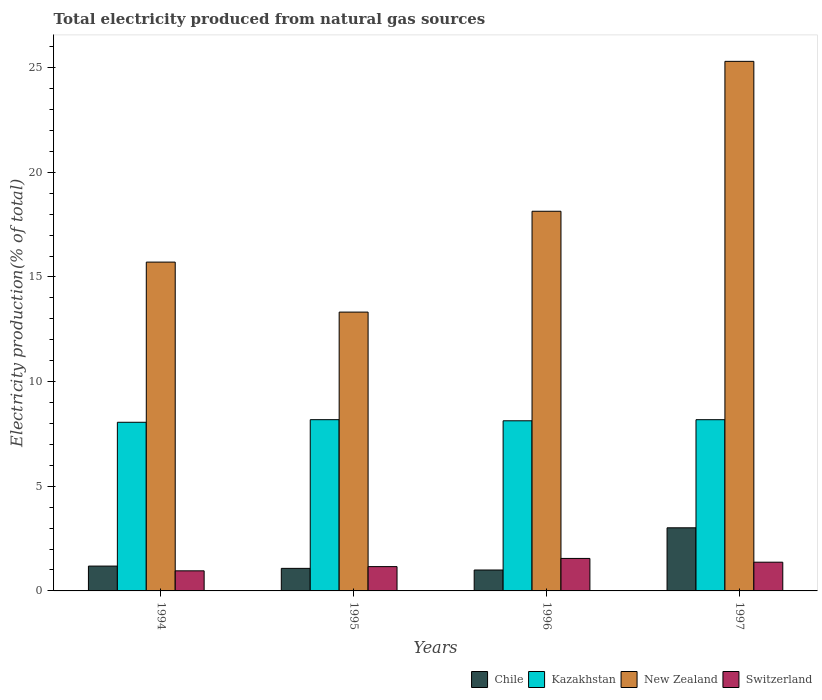Are the number of bars on each tick of the X-axis equal?
Give a very brief answer. Yes. How many bars are there on the 1st tick from the left?
Your response must be concise. 4. What is the label of the 3rd group of bars from the left?
Provide a succinct answer. 1996. In how many cases, is the number of bars for a given year not equal to the number of legend labels?
Provide a short and direct response. 0. What is the total electricity produced in Switzerland in 1994?
Make the answer very short. 0.96. Across all years, what is the maximum total electricity produced in Chile?
Offer a terse response. 3.02. Across all years, what is the minimum total electricity produced in Kazakhstan?
Provide a short and direct response. 8.06. What is the total total electricity produced in New Zealand in the graph?
Give a very brief answer. 72.47. What is the difference between the total electricity produced in Switzerland in 1995 and that in 1997?
Offer a terse response. -0.21. What is the difference between the total electricity produced in Chile in 1997 and the total electricity produced in Switzerland in 1995?
Offer a very short reply. 1.85. What is the average total electricity produced in Switzerland per year?
Your response must be concise. 1.26. In the year 1994, what is the difference between the total electricity produced in Switzerland and total electricity produced in New Zealand?
Your answer should be compact. -14.75. In how many years, is the total electricity produced in Switzerland greater than 9 %?
Provide a succinct answer. 0. What is the ratio of the total electricity produced in Switzerland in 1994 to that in 1995?
Provide a succinct answer. 0.83. Is the difference between the total electricity produced in Switzerland in 1995 and 1996 greater than the difference between the total electricity produced in New Zealand in 1995 and 1996?
Your answer should be compact. Yes. What is the difference between the highest and the second highest total electricity produced in Chile?
Provide a short and direct response. 1.83. What is the difference between the highest and the lowest total electricity produced in New Zealand?
Make the answer very short. 11.98. In how many years, is the total electricity produced in Switzerland greater than the average total electricity produced in Switzerland taken over all years?
Provide a succinct answer. 2. Is the sum of the total electricity produced in Chile in 1994 and 1997 greater than the maximum total electricity produced in Switzerland across all years?
Provide a succinct answer. Yes. What does the 4th bar from the left in 1996 represents?
Provide a short and direct response. Switzerland. What does the 2nd bar from the right in 1997 represents?
Your answer should be very brief. New Zealand. Is it the case that in every year, the sum of the total electricity produced in Chile and total electricity produced in Kazakhstan is greater than the total electricity produced in New Zealand?
Your response must be concise. No. How many bars are there?
Provide a succinct answer. 16. Are all the bars in the graph horizontal?
Offer a very short reply. No. How many years are there in the graph?
Your response must be concise. 4. What is the difference between two consecutive major ticks on the Y-axis?
Make the answer very short. 5. Are the values on the major ticks of Y-axis written in scientific E-notation?
Provide a succinct answer. No. Does the graph contain any zero values?
Make the answer very short. No. Does the graph contain grids?
Offer a very short reply. No. Where does the legend appear in the graph?
Your response must be concise. Bottom right. How many legend labels are there?
Your answer should be compact. 4. What is the title of the graph?
Offer a terse response. Total electricity produced from natural gas sources. What is the label or title of the X-axis?
Provide a succinct answer. Years. What is the Electricity production(% of total) in Chile in 1994?
Offer a terse response. 1.19. What is the Electricity production(% of total) in Kazakhstan in 1994?
Your answer should be very brief. 8.06. What is the Electricity production(% of total) of New Zealand in 1994?
Give a very brief answer. 15.71. What is the Electricity production(% of total) of Switzerland in 1994?
Your answer should be compact. 0.96. What is the Electricity production(% of total) of Chile in 1995?
Provide a short and direct response. 1.08. What is the Electricity production(% of total) in Kazakhstan in 1995?
Give a very brief answer. 8.18. What is the Electricity production(% of total) in New Zealand in 1995?
Ensure brevity in your answer.  13.32. What is the Electricity production(% of total) of Switzerland in 1995?
Give a very brief answer. 1.16. What is the Electricity production(% of total) of Chile in 1996?
Offer a terse response. 1. What is the Electricity production(% of total) in Kazakhstan in 1996?
Offer a very short reply. 8.13. What is the Electricity production(% of total) in New Zealand in 1996?
Give a very brief answer. 18.14. What is the Electricity production(% of total) of Switzerland in 1996?
Offer a very short reply. 1.55. What is the Electricity production(% of total) of Chile in 1997?
Offer a very short reply. 3.02. What is the Electricity production(% of total) in Kazakhstan in 1997?
Your response must be concise. 8.18. What is the Electricity production(% of total) of New Zealand in 1997?
Give a very brief answer. 25.3. What is the Electricity production(% of total) in Switzerland in 1997?
Offer a terse response. 1.37. Across all years, what is the maximum Electricity production(% of total) in Chile?
Provide a short and direct response. 3.02. Across all years, what is the maximum Electricity production(% of total) in Kazakhstan?
Provide a short and direct response. 8.18. Across all years, what is the maximum Electricity production(% of total) of New Zealand?
Make the answer very short. 25.3. Across all years, what is the maximum Electricity production(% of total) in Switzerland?
Offer a very short reply. 1.55. Across all years, what is the minimum Electricity production(% of total) of Chile?
Give a very brief answer. 1. Across all years, what is the minimum Electricity production(% of total) in Kazakhstan?
Your answer should be compact. 8.06. Across all years, what is the minimum Electricity production(% of total) of New Zealand?
Give a very brief answer. 13.32. Across all years, what is the minimum Electricity production(% of total) in Switzerland?
Your answer should be compact. 0.96. What is the total Electricity production(% of total) of Chile in the graph?
Provide a short and direct response. 6.28. What is the total Electricity production(% of total) of Kazakhstan in the graph?
Make the answer very short. 32.55. What is the total Electricity production(% of total) in New Zealand in the graph?
Provide a succinct answer. 72.47. What is the total Electricity production(% of total) of Switzerland in the graph?
Provide a short and direct response. 5.05. What is the difference between the Electricity production(% of total) of Chile in 1994 and that in 1995?
Ensure brevity in your answer.  0.11. What is the difference between the Electricity production(% of total) in Kazakhstan in 1994 and that in 1995?
Your answer should be compact. -0.12. What is the difference between the Electricity production(% of total) of New Zealand in 1994 and that in 1995?
Offer a terse response. 2.39. What is the difference between the Electricity production(% of total) of Switzerland in 1994 and that in 1995?
Give a very brief answer. -0.2. What is the difference between the Electricity production(% of total) in Chile in 1994 and that in 1996?
Your response must be concise. 0.19. What is the difference between the Electricity production(% of total) of Kazakhstan in 1994 and that in 1996?
Your answer should be very brief. -0.07. What is the difference between the Electricity production(% of total) of New Zealand in 1994 and that in 1996?
Give a very brief answer. -2.43. What is the difference between the Electricity production(% of total) in Switzerland in 1994 and that in 1996?
Provide a succinct answer. -0.59. What is the difference between the Electricity production(% of total) in Chile in 1994 and that in 1997?
Give a very brief answer. -1.83. What is the difference between the Electricity production(% of total) of Kazakhstan in 1994 and that in 1997?
Provide a succinct answer. -0.12. What is the difference between the Electricity production(% of total) in New Zealand in 1994 and that in 1997?
Offer a very short reply. -9.59. What is the difference between the Electricity production(% of total) in Switzerland in 1994 and that in 1997?
Keep it short and to the point. -0.41. What is the difference between the Electricity production(% of total) in Chile in 1995 and that in 1996?
Ensure brevity in your answer.  0.08. What is the difference between the Electricity production(% of total) of Kazakhstan in 1995 and that in 1996?
Provide a succinct answer. 0.05. What is the difference between the Electricity production(% of total) in New Zealand in 1995 and that in 1996?
Your answer should be very brief. -4.82. What is the difference between the Electricity production(% of total) in Switzerland in 1995 and that in 1996?
Give a very brief answer. -0.39. What is the difference between the Electricity production(% of total) of Chile in 1995 and that in 1997?
Make the answer very short. -1.94. What is the difference between the Electricity production(% of total) of Kazakhstan in 1995 and that in 1997?
Your response must be concise. 0. What is the difference between the Electricity production(% of total) of New Zealand in 1995 and that in 1997?
Keep it short and to the point. -11.98. What is the difference between the Electricity production(% of total) of Switzerland in 1995 and that in 1997?
Offer a very short reply. -0.21. What is the difference between the Electricity production(% of total) in Chile in 1996 and that in 1997?
Make the answer very short. -2.02. What is the difference between the Electricity production(% of total) of Kazakhstan in 1996 and that in 1997?
Keep it short and to the point. -0.05. What is the difference between the Electricity production(% of total) in New Zealand in 1996 and that in 1997?
Your response must be concise. -7.16. What is the difference between the Electricity production(% of total) in Switzerland in 1996 and that in 1997?
Your response must be concise. 0.18. What is the difference between the Electricity production(% of total) of Chile in 1994 and the Electricity production(% of total) of Kazakhstan in 1995?
Offer a very short reply. -6.99. What is the difference between the Electricity production(% of total) in Chile in 1994 and the Electricity production(% of total) in New Zealand in 1995?
Your response must be concise. -12.13. What is the difference between the Electricity production(% of total) of Chile in 1994 and the Electricity production(% of total) of Switzerland in 1995?
Your answer should be very brief. 0.03. What is the difference between the Electricity production(% of total) of Kazakhstan in 1994 and the Electricity production(% of total) of New Zealand in 1995?
Ensure brevity in your answer.  -5.26. What is the difference between the Electricity production(% of total) of Kazakhstan in 1994 and the Electricity production(% of total) of Switzerland in 1995?
Ensure brevity in your answer.  6.9. What is the difference between the Electricity production(% of total) of New Zealand in 1994 and the Electricity production(% of total) of Switzerland in 1995?
Provide a succinct answer. 14.55. What is the difference between the Electricity production(% of total) of Chile in 1994 and the Electricity production(% of total) of Kazakhstan in 1996?
Your response must be concise. -6.94. What is the difference between the Electricity production(% of total) in Chile in 1994 and the Electricity production(% of total) in New Zealand in 1996?
Your response must be concise. -16.95. What is the difference between the Electricity production(% of total) of Chile in 1994 and the Electricity production(% of total) of Switzerland in 1996?
Keep it short and to the point. -0.37. What is the difference between the Electricity production(% of total) in Kazakhstan in 1994 and the Electricity production(% of total) in New Zealand in 1996?
Provide a short and direct response. -10.08. What is the difference between the Electricity production(% of total) of Kazakhstan in 1994 and the Electricity production(% of total) of Switzerland in 1996?
Make the answer very short. 6.51. What is the difference between the Electricity production(% of total) of New Zealand in 1994 and the Electricity production(% of total) of Switzerland in 1996?
Your answer should be very brief. 14.16. What is the difference between the Electricity production(% of total) in Chile in 1994 and the Electricity production(% of total) in Kazakhstan in 1997?
Your response must be concise. -6.99. What is the difference between the Electricity production(% of total) of Chile in 1994 and the Electricity production(% of total) of New Zealand in 1997?
Offer a very short reply. -24.11. What is the difference between the Electricity production(% of total) in Chile in 1994 and the Electricity production(% of total) in Switzerland in 1997?
Your response must be concise. -0.19. What is the difference between the Electricity production(% of total) in Kazakhstan in 1994 and the Electricity production(% of total) in New Zealand in 1997?
Your answer should be very brief. -17.24. What is the difference between the Electricity production(% of total) in Kazakhstan in 1994 and the Electricity production(% of total) in Switzerland in 1997?
Ensure brevity in your answer.  6.68. What is the difference between the Electricity production(% of total) in New Zealand in 1994 and the Electricity production(% of total) in Switzerland in 1997?
Make the answer very short. 14.34. What is the difference between the Electricity production(% of total) of Chile in 1995 and the Electricity production(% of total) of Kazakhstan in 1996?
Make the answer very short. -7.05. What is the difference between the Electricity production(% of total) in Chile in 1995 and the Electricity production(% of total) in New Zealand in 1996?
Your answer should be compact. -17.06. What is the difference between the Electricity production(% of total) in Chile in 1995 and the Electricity production(% of total) in Switzerland in 1996?
Keep it short and to the point. -0.47. What is the difference between the Electricity production(% of total) of Kazakhstan in 1995 and the Electricity production(% of total) of New Zealand in 1996?
Make the answer very short. -9.96. What is the difference between the Electricity production(% of total) of Kazakhstan in 1995 and the Electricity production(% of total) of Switzerland in 1996?
Your answer should be compact. 6.63. What is the difference between the Electricity production(% of total) of New Zealand in 1995 and the Electricity production(% of total) of Switzerland in 1996?
Make the answer very short. 11.77. What is the difference between the Electricity production(% of total) of Chile in 1995 and the Electricity production(% of total) of Kazakhstan in 1997?
Provide a succinct answer. -7.1. What is the difference between the Electricity production(% of total) of Chile in 1995 and the Electricity production(% of total) of New Zealand in 1997?
Offer a very short reply. -24.22. What is the difference between the Electricity production(% of total) in Chile in 1995 and the Electricity production(% of total) in Switzerland in 1997?
Ensure brevity in your answer.  -0.3. What is the difference between the Electricity production(% of total) of Kazakhstan in 1995 and the Electricity production(% of total) of New Zealand in 1997?
Your answer should be very brief. -17.12. What is the difference between the Electricity production(% of total) in Kazakhstan in 1995 and the Electricity production(% of total) in Switzerland in 1997?
Your answer should be compact. 6.81. What is the difference between the Electricity production(% of total) of New Zealand in 1995 and the Electricity production(% of total) of Switzerland in 1997?
Ensure brevity in your answer.  11.95. What is the difference between the Electricity production(% of total) of Chile in 1996 and the Electricity production(% of total) of Kazakhstan in 1997?
Offer a terse response. -7.18. What is the difference between the Electricity production(% of total) in Chile in 1996 and the Electricity production(% of total) in New Zealand in 1997?
Keep it short and to the point. -24.3. What is the difference between the Electricity production(% of total) in Chile in 1996 and the Electricity production(% of total) in Switzerland in 1997?
Give a very brief answer. -0.37. What is the difference between the Electricity production(% of total) of Kazakhstan in 1996 and the Electricity production(% of total) of New Zealand in 1997?
Your answer should be compact. -17.17. What is the difference between the Electricity production(% of total) of Kazakhstan in 1996 and the Electricity production(% of total) of Switzerland in 1997?
Provide a short and direct response. 6.76. What is the difference between the Electricity production(% of total) in New Zealand in 1996 and the Electricity production(% of total) in Switzerland in 1997?
Ensure brevity in your answer.  16.77. What is the average Electricity production(% of total) in Chile per year?
Provide a short and direct response. 1.57. What is the average Electricity production(% of total) in Kazakhstan per year?
Offer a terse response. 8.14. What is the average Electricity production(% of total) in New Zealand per year?
Your answer should be very brief. 18.12. What is the average Electricity production(% of total) in Switzerland per year?
Ensure brevity in your answer.  1.26. In the year 1994, what is the difference between the Electricity production(% of total) of Chile and Electricity production(% of total) of Kazakhstan?
Offer a very short reply. -6.87. In the year 1994, what is the difference between the Electricity production(% of total) in Chile and Electricity production(% of total) in New Zealand?
Ensure brevity in your answer.  -14.52. In the year 1994, what is the difference between the Electricity production(% of total) in Chile and Electricity production(% of total) in Switzerland?
Your answer should be very brief. 0.23. In the year 1994, what is the difference between the Electricity production(% of total) of Kazakhstan and Electricity production(% of total) of New Zealand?
Provide a succinct answer. -7.65. In the year 1994, what is the difference between the Electricity production(% of total) in Kazakhstan and Electricity production(% of total) in Switzerland?
Ensure brevity in your answer.  7.1. In the year 1994, what is the difference between the Electricity production(% of total) in New Zealand and Electricity production(% of total) in Switzerland?
Your answer should be very brief. 14.75. In the year 1995, what is the difference between the Electricity production(% of total) of Chile and Electricity production(% of total) of Kazakhstan?
Make the answer very short. -7.1. In the year 1995, what is the difference between the Electricity production(% of total) of Chile and Electricity production(% of total) of New Zealand?
Your response must be concise. -12.24. In the year 1995, what is the difference between the Electricity production(% of total) of Chile and Electricity production(% of total) of Switzerland?
Your answer should be very brief. -0.08. In the year 1995, what is the difference between the Electricity production(% of total) in Kazakhstan and Electricity production(% of total) in New Zealand?
Your answer should be compact. -5.14. In the year 1995, what is the difference between the Electricity production(% of total) of Kazakhstan and Electricity production(% of total) of Switzerland?
Provide a short and direct response. 7.02. In the year 1995, what is the difference between the Electricity production(% of total) of New Zealand and Electricity production(% of total) of Switzerland?
Your response must be concise. 12.16. In the year 1996, what is the difference between the Electricity production(% of total) in Chile and Electricity production(% of total) in Kazakhstan?
Your answer should be very brief. -7.13. In the year 1996, what is the difference between the Electricity production(% of total) in Chile and Electricity production(% of total) in New Zealand?
Provide a short and direct response. -17.14. In the year 1996, what is the difference between the Electricity production(% of total) in Chile and Electricity production(% of total) in Switzerland?
Your answer should be very brief. -0.55. In the year 1996, what is the difference between the Electricity production(% of total) in Kazakhstan and Electricity production(% of total) in New Zealand?
Your answer should be compact. -10.01. In the year 1996, what is the difference between the Electricity production(% of total) of Kazakhstan and Electricity production(% of total) of Switzerland?
Offer a terse response. 6.58. In the year 1996, what is the difference between the Electricity production(% of total) of New Zealand and Electricity production(% of total) of Switzerland?
Provide a succinct answer. 16.59. In the year 1997, what is the difference between the Electricity production(% of total) in Chile and Electricity production(% of total) in Kazakhstan?
Give a very brief answer. -5.17. In the year 1997, what is the difference between the Electricity production(% of total) in Chile and Electricity production(% of total) in New Zealand?
Offer a terse response. -22.29. In the year 1997, what is the difference between the Electricity production(% of total) in Chile and Electricity production(% of total) in Switzerland?
Ensure brevity in your answer.  1.64. In the year 1997, what is the difference between the Electricity production(% of total) of Kazakhstan and Electricity production(% of total) of New Zealand?
Your answer should be very brief. -17.12. In the year 1997, what is the difference between the Electricity production(% of total) of Kazakhstan and Electricity production(% of total) of Switzerland?
Your answer should be very brief. 6.81. In the year 1997, what is the difference between the Electricity production(% of total) in New Zealand and Electricity production(% of total) in Switzerland?
Offer a terse response. 23.93. What is the ratio of the Electricity production(% of total) of Chile in 1994 to that in 1995?
Provide a succinct answer. 1.1. What is the ratio of the Electricity production(% of total) in Kazakhstan in 1994 to that in 1995?
Keep it short and to the point. 0.98. What is the ratio of the Electricity production(% of total) of New Zealand in 1994 to that in 1995?
Your answer should be compact. 1.18. What is the ratio of the Electricity production(% of total) in Switzerland in 1994 to that in 1995?
Keep it short and to the point. 0.83. What is the ratio of the Electricity production(% of total) in Chile in 1994 to that in 1996?
Your answer should be compact. 1.19. What is the ratio of the Electricity production(% of total) of New Zealand in 1994 to that in 1996?
Your answer should be very brief. 0.87. What is the ratio of the Electricity production(% of total) in Switzerland in 1994 to that in 1996?
Your answer should be compact. 0.62. What is the ratio of the Electricity production(% of total) in Chile in 1994 to that in 1997?
Your answer should be compact. 0.39. What is the ratio of the Electricity production(% of total) in Kazakhstan in 1994 to that in 1997?
Your answer should be compact. 0.98. What is the ratio of the Electricity production(% of total) in New Zealand in 1994 to that in 1997?
Your response must be concise. 0.62. What is the ratio of the Electricity production(% of total) in Switzerland in 1994 to that in 1997?
Give a very brief answer. 0.7. What is the ratio of the Electricity production(% of total) of Chile in 1995 to that in 1996?
Keep it short and to the point. 1.08. What is the ratio of the Electricity production(% of total) of New Zealand in 1995 to that in 1996?
Keep it short and to the point. 0.73. What is the ratio of the Electricity production(% of total) of Switzerland in 1995 to that in 1996?
Offer a terse response. 0.75. What is the ratio of the Electricity production(% of total) of Chile in 1995 to that in 1997?
Give a very brief answer. 0.36. What is the ratio of the Electricity production(% of total) in Kazakhstan in 1995 to that in 1997?
Offer a very short reply. 1. What is the ratio of the Electricity production(% of total) of New Zealand in 1995 to that in 1997?
Keep it short and to the point. 0.53. What is the ratio of the Electricity production(% of total) of Switzerland in 1995 to that in 1997?
Offer a very short reply. 0.85. What is the ratio of the Electricity production(% of total) of Chile in 1996 to that in 1997?
Provide a succinct answer. 0.33. What is the ratio of the Electricity production(% of total) in New Zealand in 1996 to that in 1997?
Your answer should be very brief. 0.72. What is the ratio of the Electricity production(% of total) of Switzerland in 1996 to that in 1997?
Your response must be concise. 1.13. What is the difference between the highest and the second highest Electricity production(% of total) in Chile?
Provide a succinct answer. 1.83. What is the difference between the highest and the second highest Electricity production(% of total) in Kazakhstan?
Offer a terse response. 0. What is the difference between the highest and the second highest Electricity production(% of total) in New Zealand?
Make the answer very short. 7.16. What is the difference between the highest and the second highest Electricity production(% of total) in Switzerland?
Your answer should be very brief. 0.18. What is the difference between the highest and the lowest Electricity production(% of total) of Chile?
Your answer should be very brief. 2.02. What is the difference between the highest and the lowest Electricity production(% of total) in Kazakhstan?
Your response must be concise. 0.12. What is the difference between the highest and the lowest Electricity production(% of total) of New Zealand?
Your answer should be compact. 11.98. What is the difference between the highest and the lowest Electricity production(% of total) in Switzerland?
Make the answer very short. 0.59. 